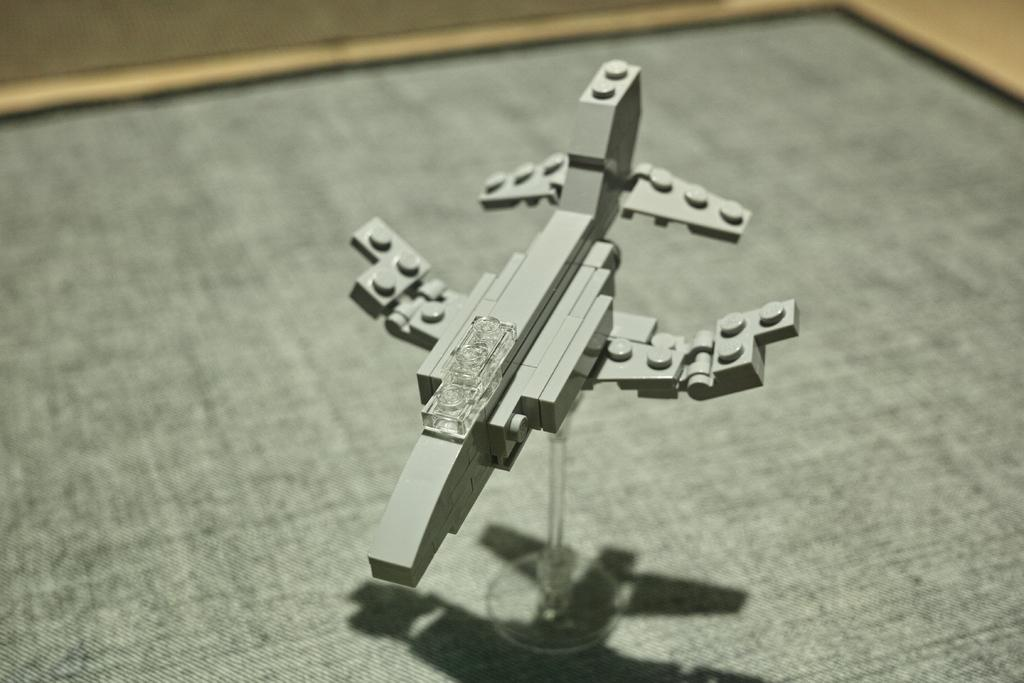What is the main subject of the picture? The main subject of the picture is a Lego airplane. Does the Lego airplane have any specific features? Yes, the Lego airplane has a stand. What can be observed about the background of the image? The background of the image is blurred. What type of elbow can be seen in the image? There is no elbow present in the image; it features a Lego airplane with a stand. What is the condition of the juice in the image? There is no juice present in the image. 